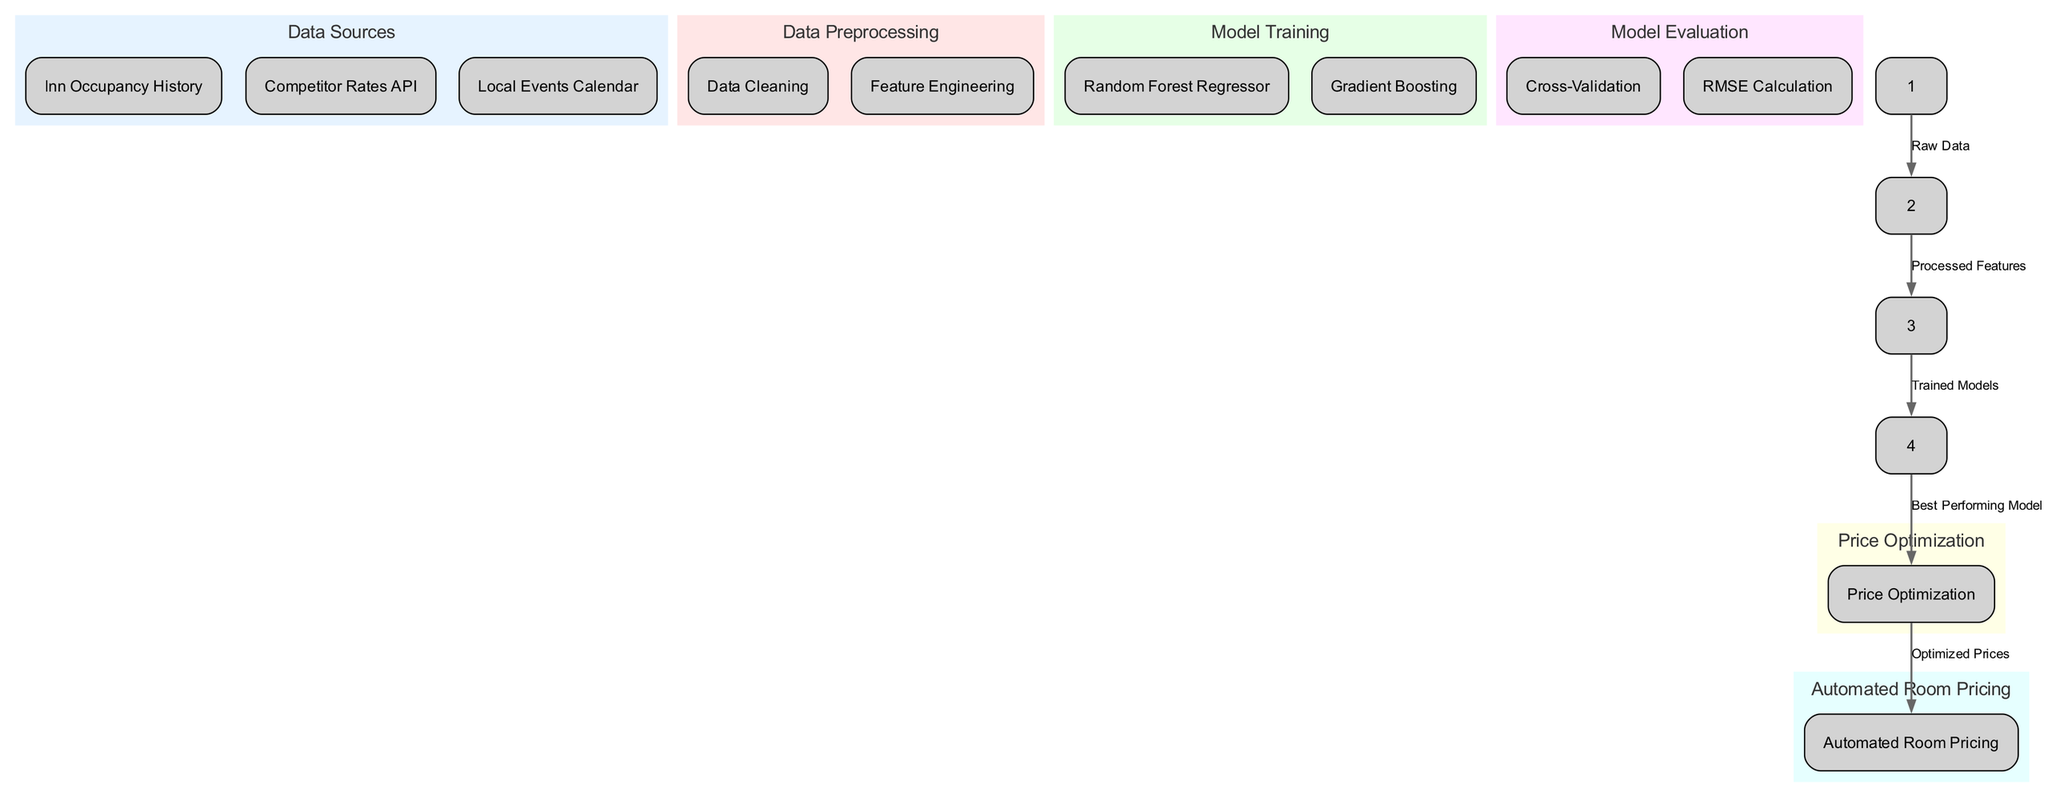What are the three data sources in the diagram? The diagram lists three primary data sources under the "Data Sources" node: "Inn Occupancy History", "Competitor Rates API", and "Local Events Calendar".
Answer: Inn Occupancy History, Competitor Rates API, Local Events Calendar How many types of model training methods are shown in the diagram? Under the "Model Training" node, there are two methods listed: "Random Forest Regressor" and "Gradient Boosting". Thus, there are two types of model training methods.
Answer: 2 What is the final output of the machine learning pipeline according to the diagram? The final node indicates that the output of the machine learning pipeline is "Automated Room Pricing", which is derived from previous steps.
Answer: Automated Room Pricing Which process follows "Data Preprocessing"? According to the flow in the diagram, "Model Training" comes next after "Data Preprocessing", showing the sequential steps involved in the pipeline.
Answer: Model Training What is the relationship between "Model Evaluation" and "Price Optimization"? The diagram shows that "Price Optimization" follows "Model Evaluation", indicating that the evaluation process influences how prices will be optimized based on the performance of the models.
Answer: Best Performing Model What type of evaluation method is used in the diagram? Under the "Model Evaluation" node, "Cross-Validation" is specified as a method used for evaluating the trained models, providing a way to assess their performance.
Answer: Cross-Validation What is the purpose of "Feature Engineering" in the pipeline? "Feature Engineering" is part of "Data Preprocessing", aimed at transforming raw data into a format suitable for model training, thereby enhancing model performance and accuracy.
Answer: Processed Features Which step directly connects to "Best Performing Model"? According to the diagram, "Model Evaluation" directly provides the "Best Performing Model", as the first step in optimizing prices based on the performance metrics.
Answer: Model Evaluation 